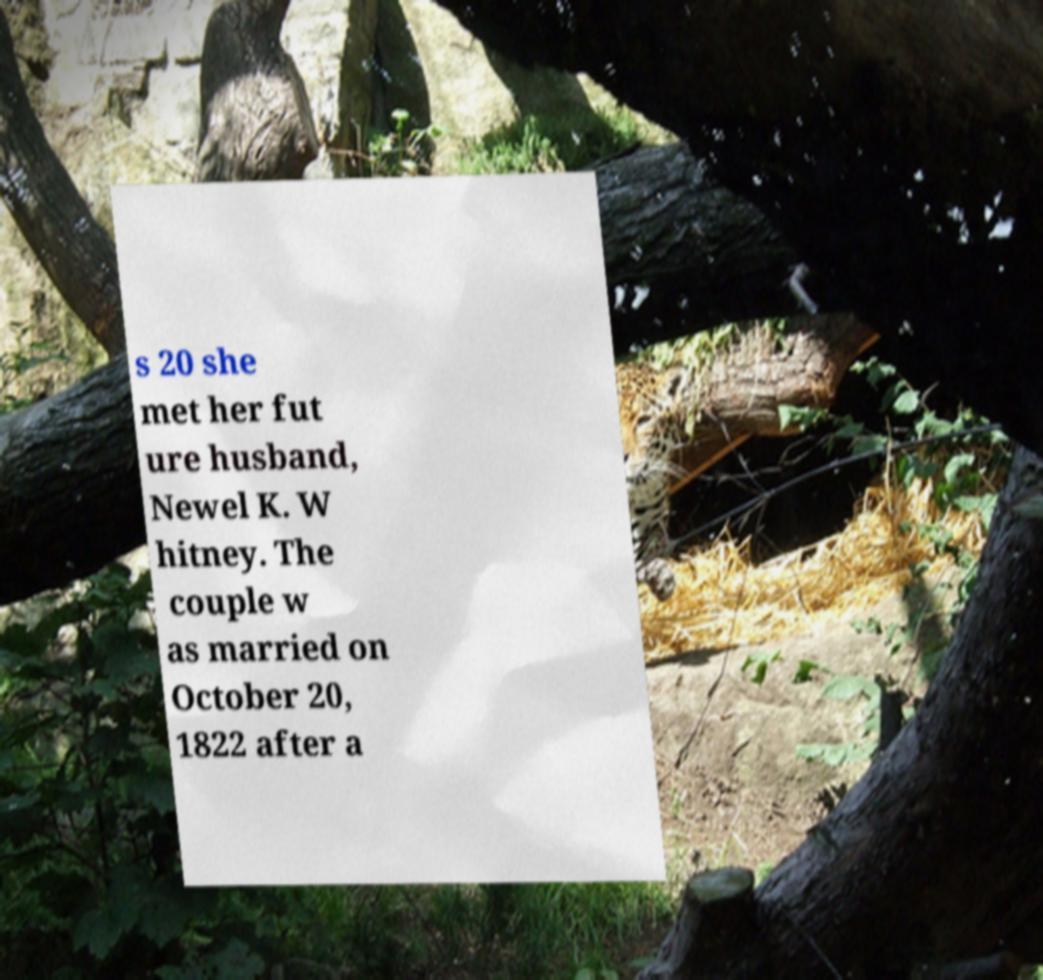Could you extract and type out the text from this image? s 20 she met her fut ure husband, Newel K. W hitney. The couple w as married on October 20, 1822 after a 